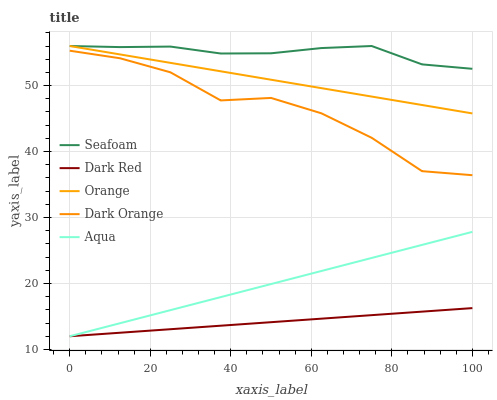Does Aqua have the minimum area under the curve?
Answer yes or no. No. Does Aqua have the maximum area under the curve?
Answer yes or no. No. Is Dark Red the smoothest?
Answer yes or no. No. Is Dark Red the roughest?
Answer yes or no. No. Does Seafoam have the lowest value?
Answer yes or no. No. Does Aqua have the highest value?
Answer yes or no. No. Is Dark Red less than Seafoam?
Answer yes or no. Yes. Is Orange greater than Dark Orange?
Answer yes or no. Yes. Does Dark Red intersect Seafoam?
Answer yes or no. No. 